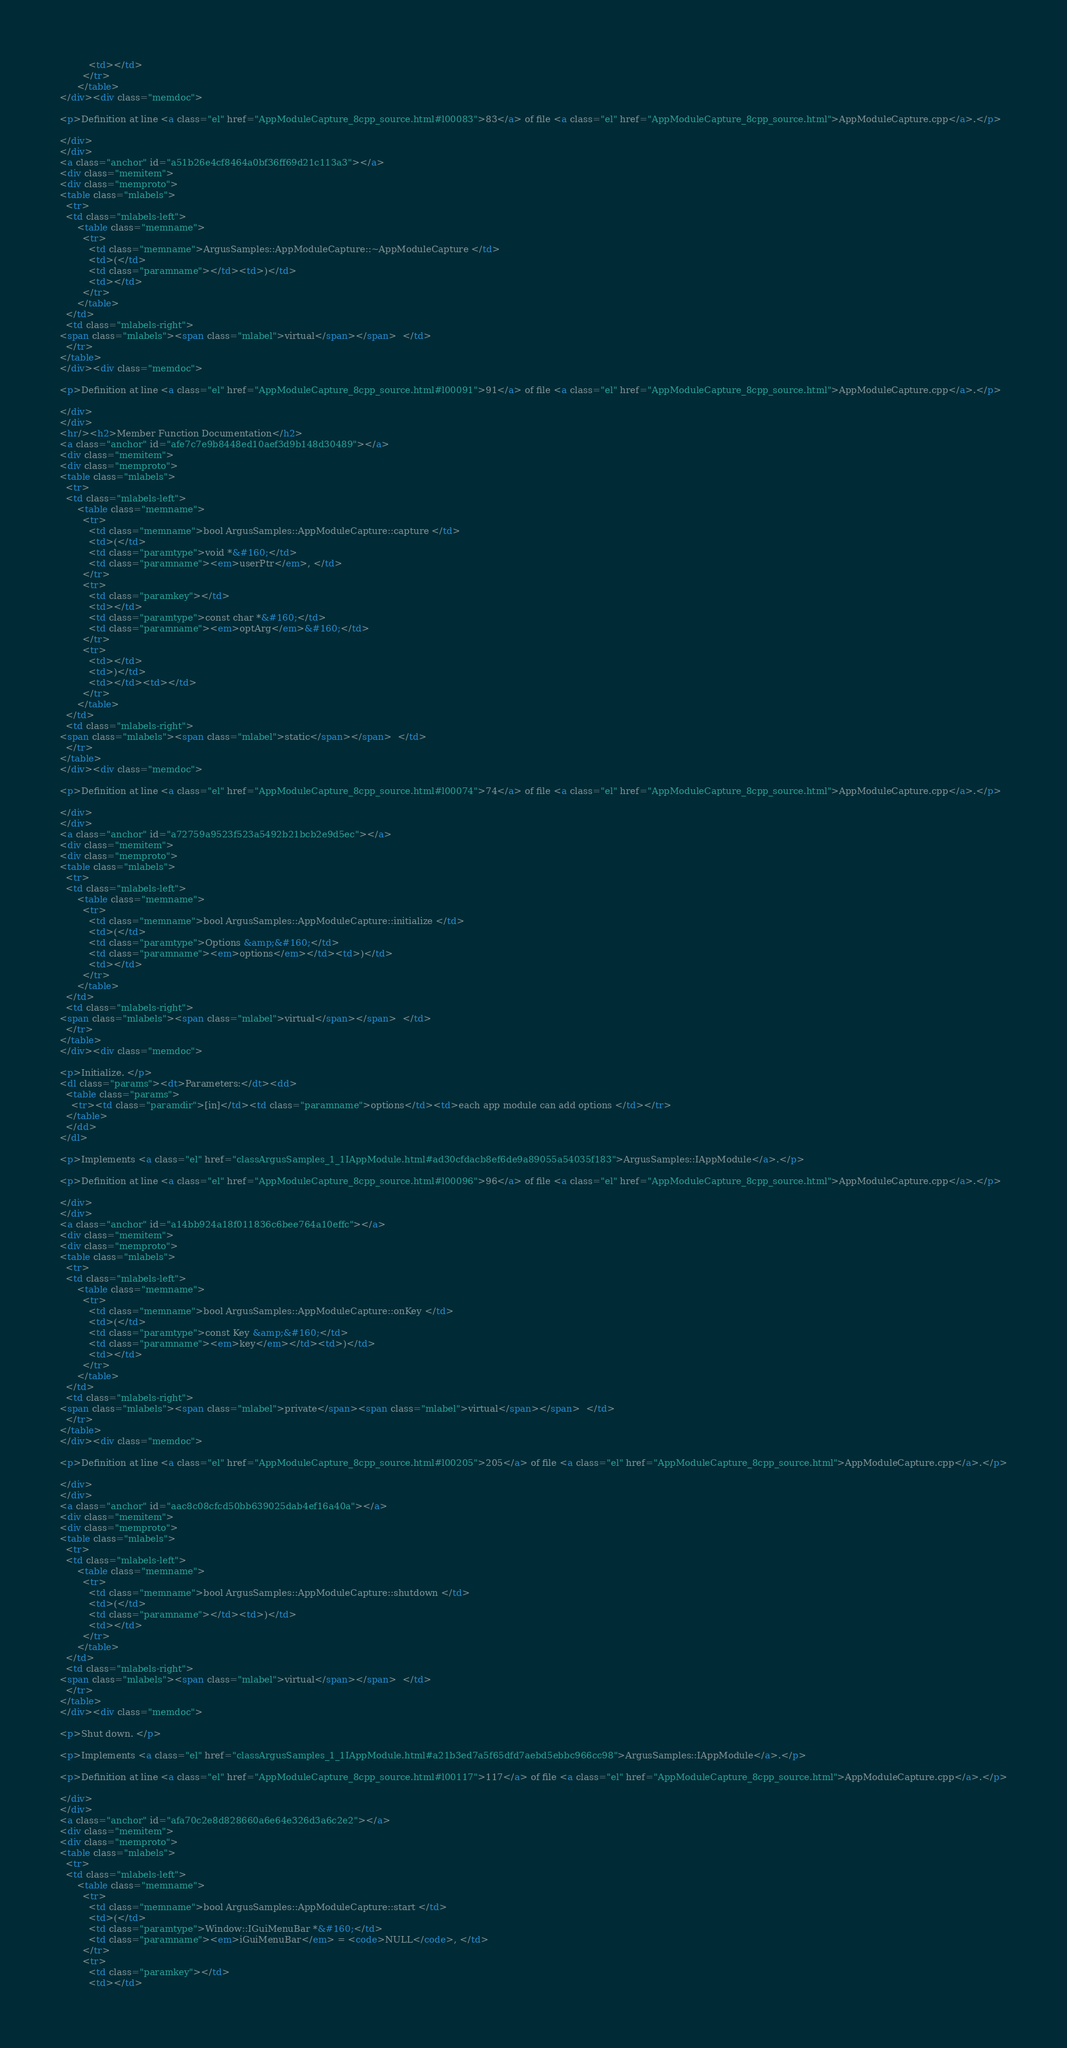Convert code to text. <code><loc_0><loc_0><loc_500><loc_500><_HTML_>          <td></td>
        </tr>
      </table>
</div><div class="memdoc">

<p>Definition at line <a class="el" href="AppModuleCapture_8cpp_source.html#l00083">83</a> of file <a class="el" href="AppModuleCapture_8cpp_source.html">AppModuleCapture.cpp</a>.</p>

</div>
</div>
<a class="anchor" id="a51b26e4cf8464a0bf36ff69d21c113a3"></a>
<div class="memitem">
<div class="memproto">
<table class="mlabels">
  <tr>
  <td class="mlabels-left">
      <table class="memname">
        <tr>
          <td class="memname">ArgusSamples::AppModuleCapture::~AppModuleCapture </td>
          <td>(</td>
          <td class="paramname"></td><td>)</td>
          <td></td>
        </tr>
      </table>
  </td>
  <td class="mlabels-right">
<span class="mlabels"><span class="mlabel">virtual</span></span>  </td>
  </tr>
</table>
</div><div class="memdoc">

<p>Definition at line <a class="el" href="AppModuleCapture_8cpp_source.html#l00091">91</a> of file <a class="el" href="AppModuleCapture_8cpp_source.html">AppModuleCapture.cpp</a>.</p>

</div>
</div>
<hr/><h2>Member Function Documentation</h2>
<a class="anchor" id="afe7c7e9b8448ed10aef3d9b148d30489"></a>
<div class="memitem">
<div class="memproto">
<table class="mlabels">
  <tr>
  <td class="mlabels-left">
      <table class="memname">
        <tr>
          <td class="memname">bool ArgusSamples::AppModuleCapture::capture </td>
          <td>(</td>
          <td class="paramtype">void *&#160;</td>
          <td class="paramname"><em>userPtr</em>, </td>
        </tr>
        <tr>
          <td class="paramkey"></td>
          <td></td>
          <td class="paramtype">const char *&#160;</td>
          <td class="paramname"><em>optArg</em>&#160;</td>
        </tr>
        <tr>
          <td></td>
          <td>)</td>
          <td></td><td></td>
        </tr>
      </table>
  </td>
  <td class="mlabels-right">
<span class="mlabels"><span class="mlabel">static</span></span>  </td>
  </tr>
</table>
</div><div class="memdoc">

<p>Definition at line <a class="el" href="AppModuleCapture_8cpp_source.html#l00074">74</a> of file <a class="el" href="AppModuleCapture_8cpp_source.html">AppModuleCapture.cpp</a>.</p>

</div>
</div>
<a class="anchor" id="a72759a9523f523a5492b21bcb2e9d5ec"></a>
<div class="memitem">
<div class="memproto">
<table class="mlabels">
  <tr>
  <td class="mlabels-left">
      <table class="memname">
        <tr>
          <td class="memname">bool ArgusSamples::AppModuleCapture::initialize </td>
          <td>(</td>
          <td class="paramtype">Options &amp;&#160;</td>
          <td class="paramname"><em>options</em></td><td>)</td>
          <td></td>
        </tr>
      </table>
  </td>
  <td class="mlabels-right">
<span class="mlabels"><span class="mlabel">virtual</span></span>  </td>
  </tr>
</table>
</div><div class="memdoc">

<p>Initialize. </p>
<dl class="params"><dt>Parameters:</dt><dd>
  <table class="params">
    <tr><td class="paramdir">[in]</td><td class="paramname">options</td><td>each app module can add options </td></tr>
  </table>
  </dd>
</dl>

<p>Implements <a class="el" href="classArgusSamples_1_1IAppModule.html#ad30cfdacb8ef6de9a89055a54035f183">ArgusSamples::IAppModule</a>.</p>

<p>Definition at line <a class="el" href="AppModuleCapture_8cpp_source.html#l00096">96</a> of file <a class="el" href="AppModuleCapture_8cpp_source.html">AppModuleCapture.cpp</a>.</p>

</div>
</div>
<a class="anchor" id="a14bb924a18f011836c6bee764a10effc"></a>
<div class="memitem">
<div class="memproto">
<table class="mlabels">
  <tr>
  <td class="mlabels-left">
      <table class="memname">
        <tr>
          <td class="memname">bool ArgusSamples::AppModuleCapture::onKey </td>
          <td>(</td>
          <td class="paramtype">const Key &amp;&#160;</td>
          <td class="paramname"><em>key</em></td><td>)</td>
          <td></td>
        </tr>
      </table>
  </td>
  <td class="mlabels-right">
<span class="mlabels"><span class="mlabel">private</span><span class="mlabel">virtual</span></span>  </td>
  </tr>
</table>
</div><div class="memdoc">

<p>Definition at line <a class="el" href="AppModuleCapture_8cpp_source.html#l00205">205</a> of file <a class="el" href="AppModuleCapture_8cpp_source.html">AppModuleCapture.cpp</a>.</p>

</div>
</div>
<a class="anchor" id="aac8c08cfcd50bb639025dab4ef16a40a"></a>
<div class="memitem">
<div class="memproto">
<table class="mlabels">
  <tr>
  <td class="mlabels-left">
      <table class="memname">
        <tr>
          <td class="memname">bool ArgusSamples::AppModuleCapture::shutdown </td>
          <td>(</td>
          <td class="paramname"></td><td>)</td>
          <td></td>
        </tr>
      </table>
  </td>
  <td class="mlabels-right">
<span class="mlabels"><span class="mlabel">virtual</span></span>  </td>
  </tr>
</table>
</div><div class="memdoc">

<p>Shut down. </p>

<p>Implements <a class="el" href="classArgusSamples_1_1IAppModule.html#a21b3ed7a5f65dfd7aebd5ebbc966cc98">ArgusSamples::IAppModule</a>.</p>

<p>Definition at line <a class="el" href="AppModuleCapture_8cpp_source.html#l00117">117</a> of file <a class="el" href="AppModuleCapture_8cpp_source.html">AppModuleCapture.cpp</a>.</p>

</div>
</div>
<a class="anchor" id="afa70c2e8d828660a6e64e326d3a6c2e2"></a>
<div class="memitem">
<div class="memproto">
<table class="mlabels">
  <tr>
  <td class="mlabels-left">
      <table class="memname">
        <tr>
          <td class="memname">bool ArgusSamples::AppModuleCapture::start </td>
          <td>(</td>
          <td class="paramtype">Window::IGuiMenuBar *&#160;</td>
          <td class="paramname"><em>iGuiMenuBar</em> = <code>NULL</code>, </td>
        </tr>
        <tr>
          <td class="paramkey"></td>
          <td></td></code> 